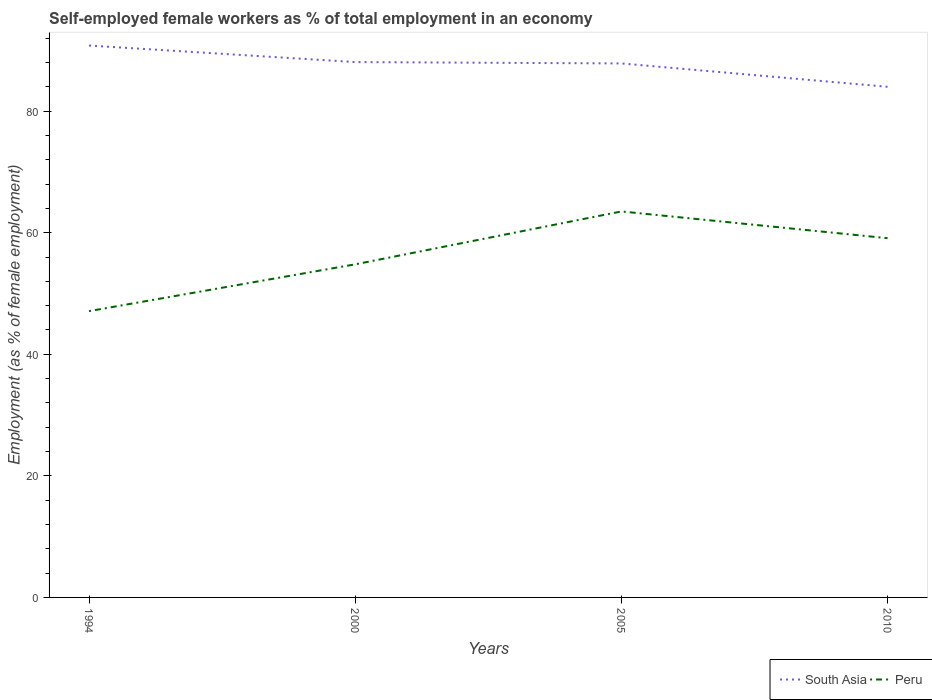How many different coloured lines are there?
Provide a succinct answer. 2. Does the line corresponding to Peru intersect with the line corresponding to South Asia?
Offer a very short reply. No. Is the number of lines equal to the number of legend labels?
Your answer should be compact. Yes. Across all years, what is the maximum percentage of self-employed female workers in South Asia?
Keep it short and to the point. 84.01. In which year was the percentage of self-employed female workers in Peru maximum?
Offer a terse response. 1994. What is the total percentage of self-employed female workers in Peru in the graph?
Your answer should be compact. -4.3. What is the difference between the highest and the second highest percentage of self-employed female workers in South Asia?
Offer a very short reply. 6.79. What is the difference between the highest and the lowest percentage of self-employed female workers in South Asia?
Provide a succinct answer. 3. Does the graph contain grids?
Offer a terse response. No. How many legend labels are there?
Your response must be concise. 2. What is the title of the graph?
Keep it short and to the point. Self-employed female workers as % of total employment in an economy. What is the label or title of the Y-axis?
Your answer should be very brief. Employment (as % of female employment). What is the Employment (as % of female employment) of South Asia in 1994?
Keep it short and to the point. 90.79. What is the Employment (as % of female employment) in Peru in 1994?
Offer a terse response. 47.1. What is the Employment (as % of female employment) of South Asia in 2000?
Your answer should be compact. 88.07. What is the Employment (as % of female employment) in Peru in 2000?
Ensure brevity in your answer.  54.8. What is the Employment (as % of female employment) in South Asia in 2005?
Provide a succinct answer. 87.85. What is the Employment (as % of female employment) in Peru in 2005?
Your response must be concise. 63.5. What is the Employment (as % of female employment) in South Asia in 2010?
Ensure brevity in your answer.  84.01. What is the Employment (as % of female employment) of Peru in 2010?
Give a very brief answer. 59.1. Across all years, what is the maximum Employment (as % of female employment) in South Asia?
Your response must be concise. 90.79. Across all years, what is the maximum Employment (as % of female employment) in Peru?
Offer a very short reply. 63.5. Across all years, what is the minimum Employment (as % of female employment) in South Asia?
Make the answer very short. 84.01. Across all years, what is the minimum Employment (as % of female employment) of Peru?
Your answer should be very brief. 47.1. What is the total Employment (as % of female employment) in South Asia in the graph?
Offer a terse response. 350.72. What is the total Employment (as % of female employment) of Peru in the graph?
Keep it short and to the point. 224.5. What is the difference between the Employment (as % of female employment) in South Asia in 1994 and that in 2000?
Provide a short and direct response. 2.72. What is the difference between the Employment (as % of female employment) of South Asia in 1994 and that in 2005?
Make the answer very short. 2.95. What is the difference between the Employment (as % of female employment) of Peru in 1994 and that in 2005?
Your answer should be compact. -16.4. What is the difference between the Employment (as % of female employment) in South Asia in 1994 and that in 2010?
Ensure brevity in your answer.  6.79. What is the difference between the Employment (as % of female employment) in South Asia in 2000 and that in 2005?
Ensure brevity in your answer.  0.22. What is the difference between the Employment (as % of female employment) in South Asia in 2000 and that in 2010?
Provide a succinct answer. 4.07. What is the difference between the Employment (as % of female employment) in South Asia in 2005 and that in 2010?
Make the answer very short. 3.84. What is the difference between the Employment (as % of female employment) in South Asia in 1994 and the Employment (as % of female employment) in Peru in 2000?
Keep it short and to the point. 35.99. What is the difference between the Employment (as % of female employment) in South Asia in 1994 and the Employment (as % of female employment) in Peru in 2005?
Give a very brief answer. 27.29. What is the difference between the Employment (as % of female employment) of South Asia in 1994 and the Employment (as % of female employment) of Peru in 2010?
Keep it short and to the point. 31.69. What is the difference between the Employment (as % of female employment) in South Asia in 2000 and the Employment (as % of female employment) in Peru in 2005?
Offer a terse response. 24.57. What is the difference between the Employment (as % of female employment) in South Asia in 2000 and the Employment (as % of female employment) in Peru in 2010?
Your response must be concise. 28.97. What is the difference between the Employment (as % of female employment) of South Asia in 2005 and the Employment (as % of female employment) of Peru in 2010?
Make the answer very short. 28.75. What is the average Employment (as % of female employment) in South Asia per year?
Your answer should be compact. 87.68. What is the average Employment (as % of female employment) of Peru per year?
Provide a succinct answer. 56.12. In the year 1994, what is the difference between the Employment (as % of female employment) of South Asia and Employment (as % of female employment) of Peru?
Provide a succinct answer. 43.69. In the year 2000, what is the difference between the Employment (as % of female employment) of South Asia and Employment (as % of female employment) of Peru?
Keep it short and to the point. 33.27. In the year 2005, what is the difference between the Employment (as % of female employment) of South Asia and Employment (as % of female employment) of Peru?
Make the answer very short. 24.35. In the year 2010, what is the difference between the Employment (as % of female employment) in South Asia and Employment (as % of female employment) in Peru?
Offer a very short reply. 24.91. What is the ratio of the Employment (as % of female employment) of South Asia in 1994 to that in 2000?
Your response must be concise. 1.03. What is the ratio of the Employment (as % of female employment) in Peru in 1994 to that in 2000?
Make the answer very short. 0.86. What is the ratio of the Employment (as % of female employment) in South Asia in 1994 to that in 2005?
Your answer should be compact. 1.03. What is the ratio of the Employment (as % of female employment) of Peru in 1994 to that in 2005?
Give a very brief answer. 0.74. What is the ratio of the Employment (as % of female employment) of South Asia in 1994 to that in 2010?
Make the answer very short. 1.08. What is the ratio of the Employment (as % of female employment) of Peru in 1994 to that in 2010?
Offer a terse response. 0.8. What is the ratio of the Employment (as % of female employment) of South Asia in 2000 to that in 2005?
Give a very brief answer. 1. What is the ratio of the Employment (as % of female employment) in Peru in 2000 to that in 2005?
Your answer should be very brief. 0.86. What is the ratio of the Employment (as % of female employment) of South Asia in 2000 to that in 2010?
Ensure brevity in your answer.  1.05. What is the ratio of the Employment (as % of female employment) of Peru in 2000 to that in 2010?
Ensure brevity in your answer.  0.93. What is the ratio of the Employment (as % of female employment) in South Asia in 2005 to that in 2010?
Your answer should be compact. 1.05. What is the ratio of the Employment (as % of female employment) in Peru in 2005 to that in 2010?
Provide a succinct answer. 1.07. What is the difference between the highest and the second highest Employment (as % of female employment) in South Asia?
Ensure brevity in your answer.  2.72. What is the difference between the highest and the lowest Employment (as % of female employment) of South Asia?
Your response must be concise. 6.79. 